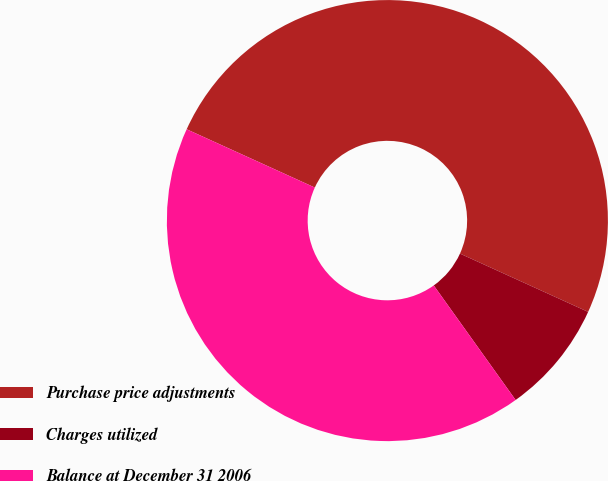<chart> <loc_0><loc_0><loc_500><loc_500><pie_chart><fcel>Purchase price adjustments<fcel>Charges utilized<fcel>Balance at December 31 2006<nl><fcel>50.0%<fcel>8.33%<fcel>41.67%<nl></chart> 